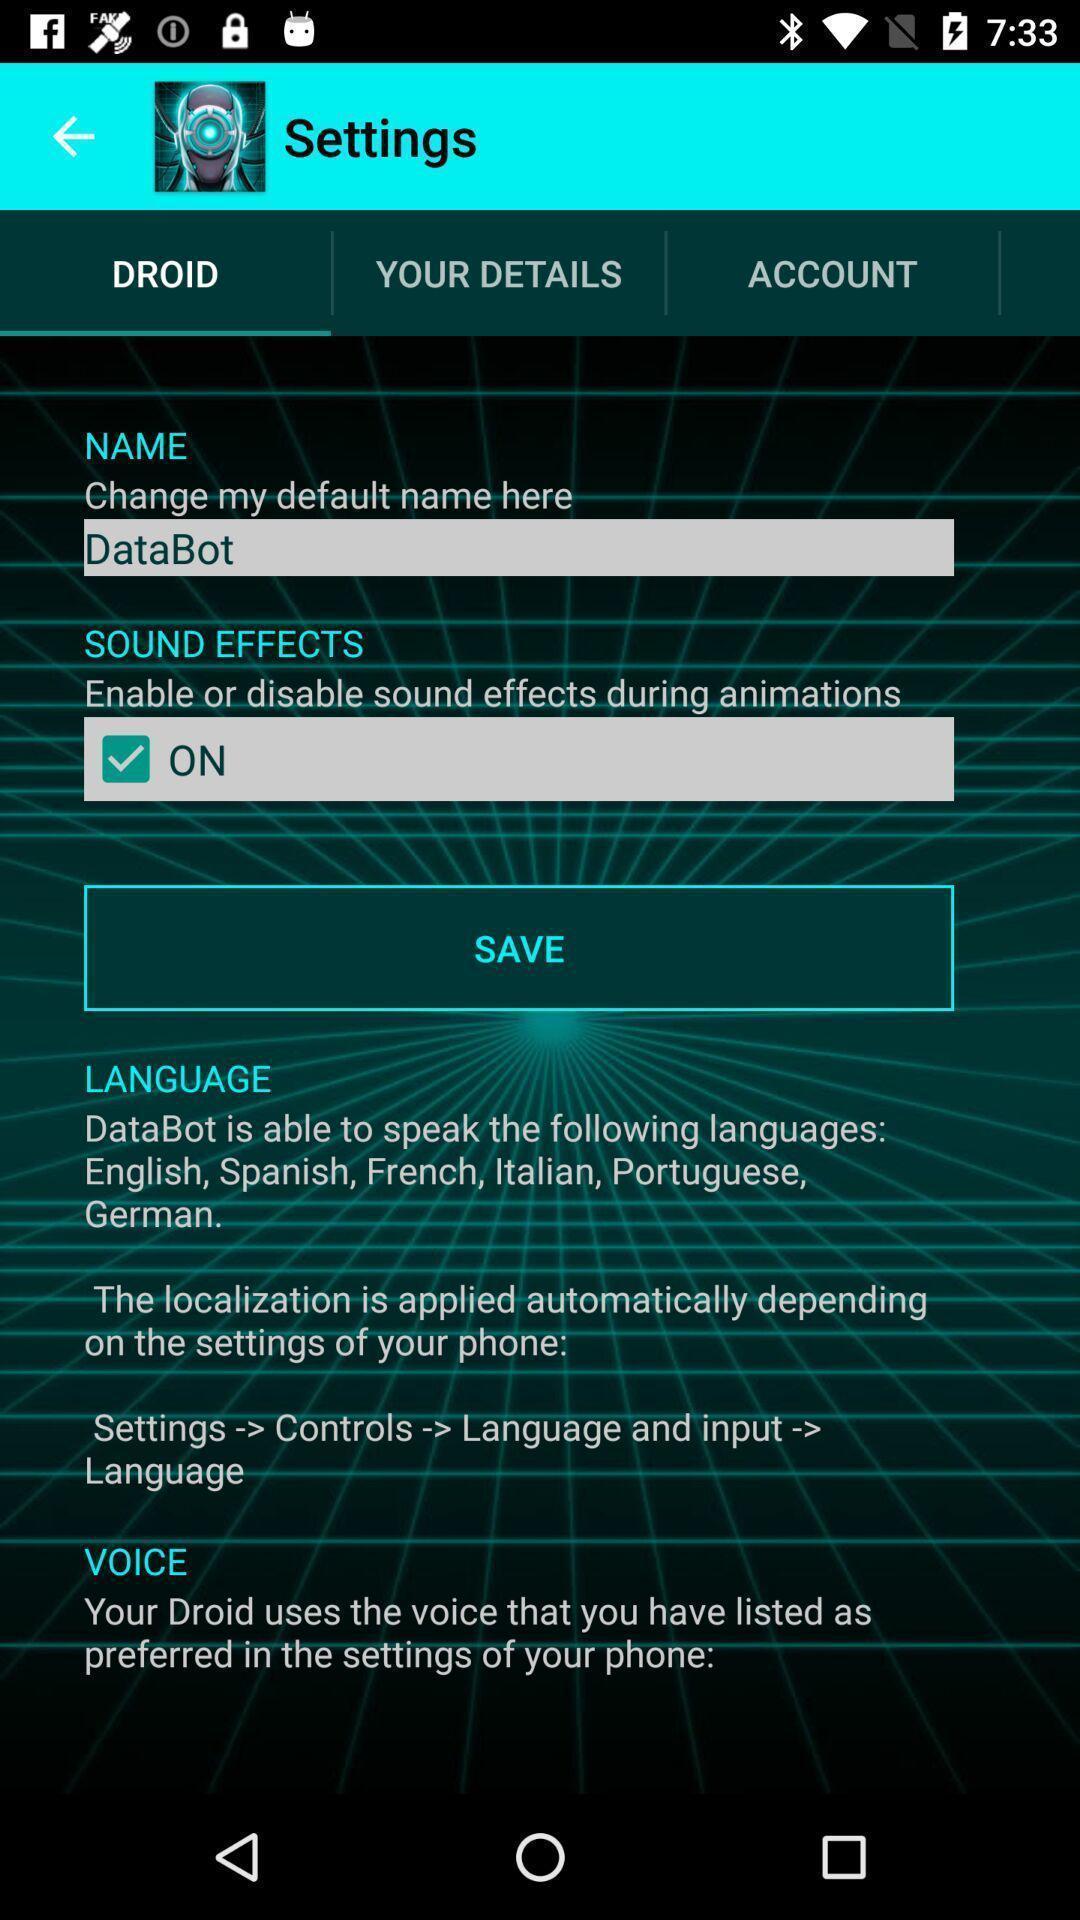Describe this image in words. Screen showing settings. 